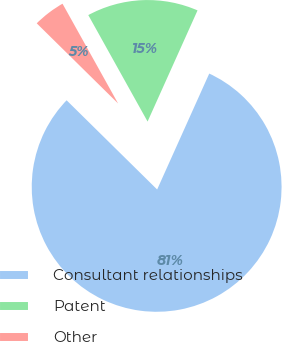Convert chart. <chart><loc_0><loc_0><loc_500><loc_500><pie_chart><fcel>Consultant relationships<fcel>Patent<fcel>Other<nl><fcel>80.66%<fcel>14.81%<fcel>4.53%<nl></chart> 